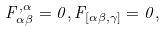Convert formula to latex. <formula><loc_0><loc_0><loc_500><loc_500>F ^ { , \alpha } _ { \alpha \beta } = 0 , F _ { [ \alpha \beta , \gamma ] } = 0 ,</formula> 